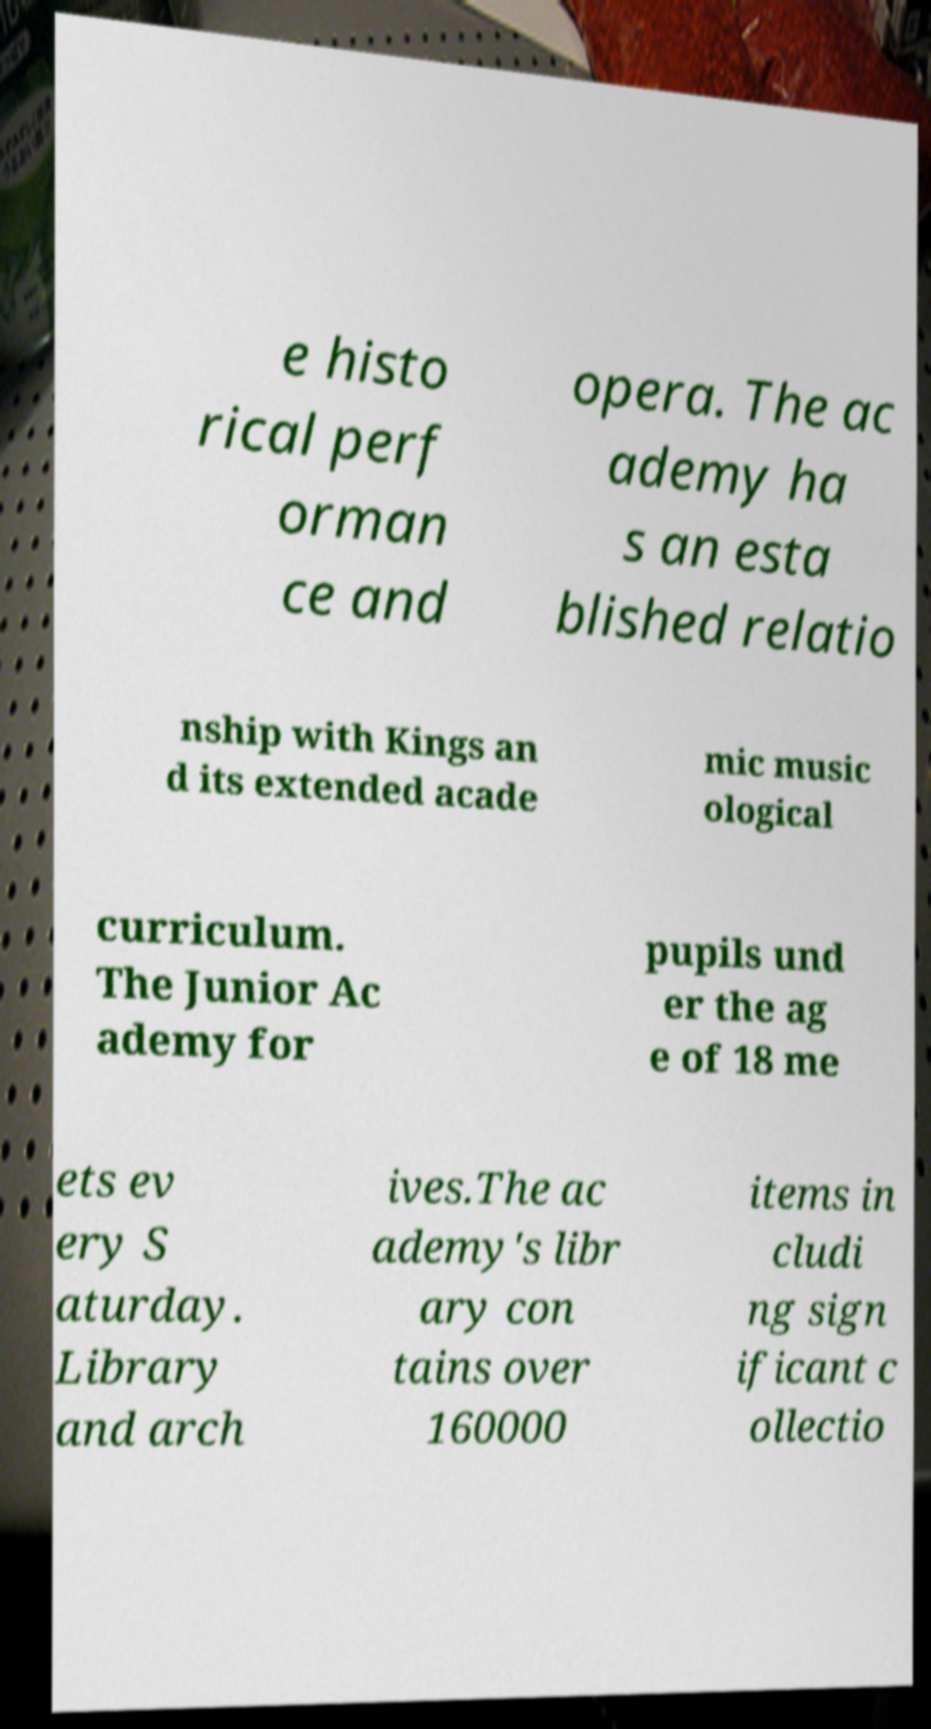Could you extract and type out the text from this image? e histo rical perf orman ce and opera. The ac ademy ha s an esta blished relatio nship with Kings an d its extended acade mic music ological curriculum. The Junior Ac ademy for pupils und er the ag e of 18 me ets ev ery S aturday. Library and arch ives.The ac ademy's libr ary con tains over 160000 items in cludi ng sign ificant c ollectio 